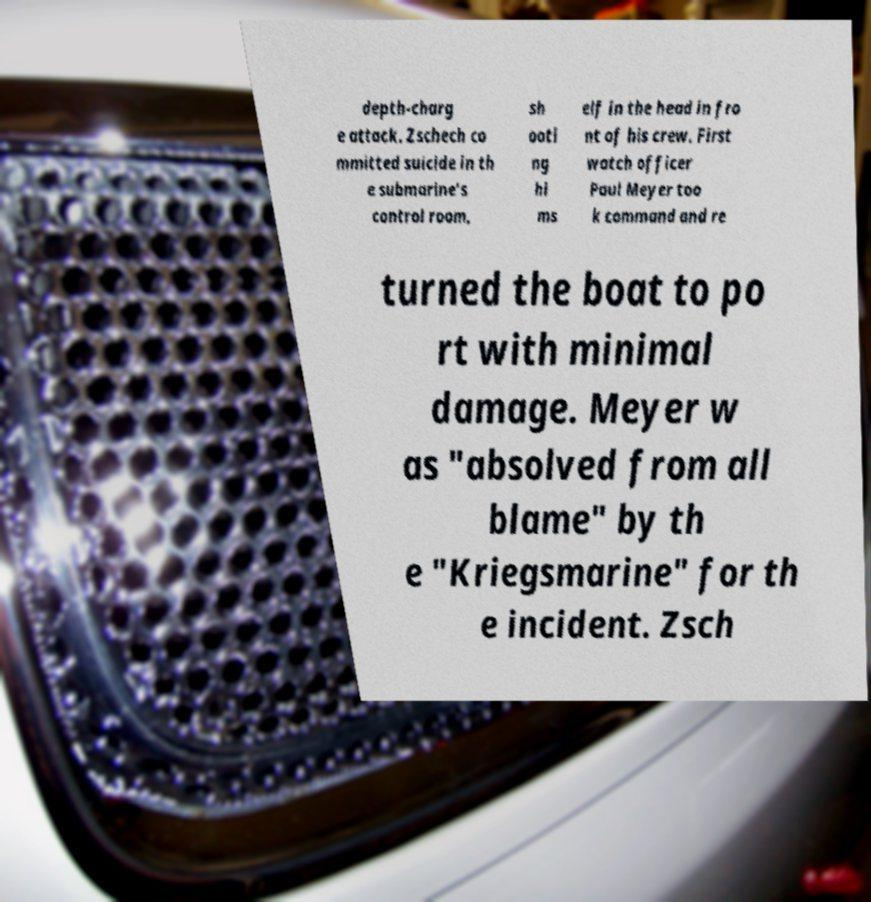For documentation purposes, I need the text within this image transcribed. Could you provide that? depth-charg e attack. Zschech co mmitted suicide in th e submarine's control room, sh ooti ng hi ms elf in the head in fro nt of his crew. First watch officer Paul Meyer too k command and re turned the boat to po rt with minimal damage. Meyer w as "absolved from all blame" by th e "Kriegsmarine" for th e incident. Zsch 